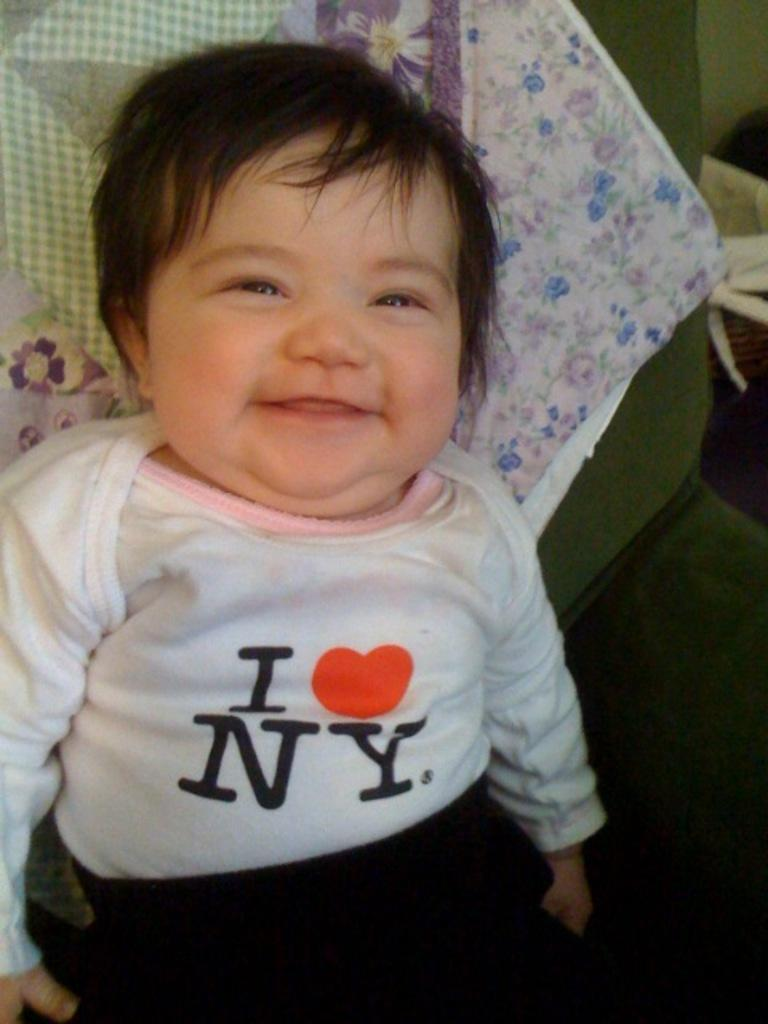Who is the main subject in the image? There is a little boy in the image. What is the boy's expression in the image? The boy is smiling in the image. What color is the boy's t-shirt in the image? The boy is wearing a white t-shirt in the image. What color are the boy's shorts in the image? The boy is wearing black shorts in the image. What type of crown is the boy wearing in the image? There is no crown present in the image. 